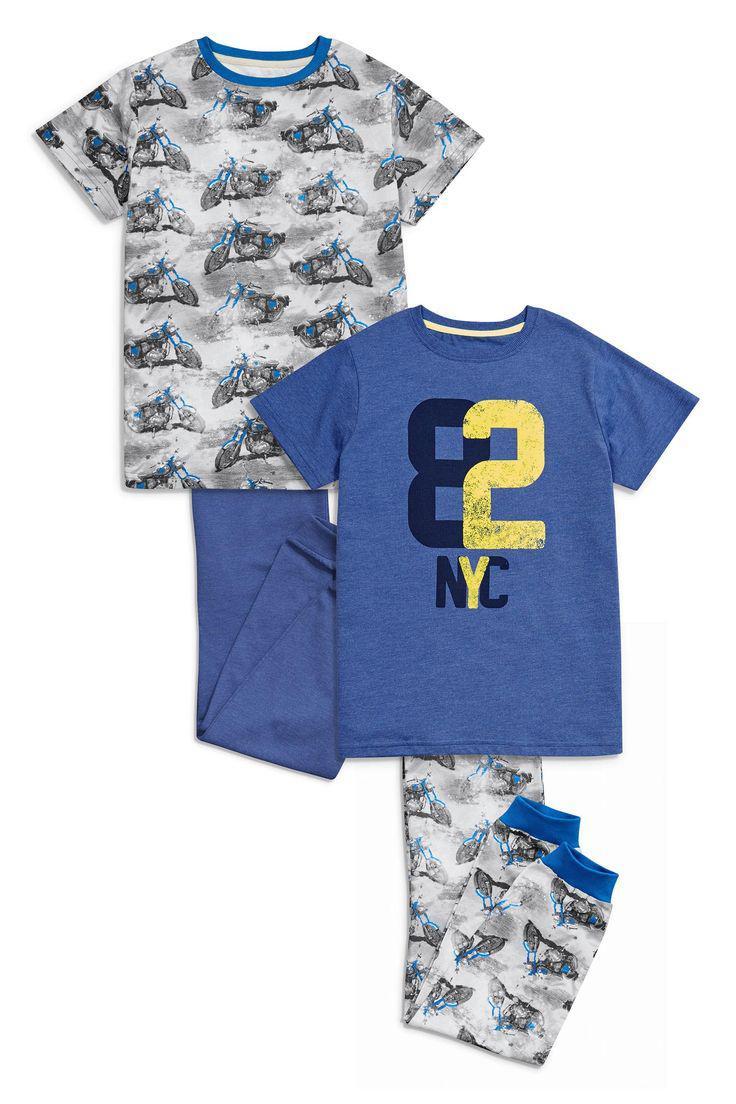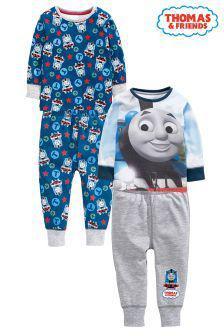The first image is the image on the left, the second image is the image on the right. Analyze the images presented: Is the assertion "No individual image contains more than two sets of sleepwear, and the right image includes a pajama top depicting a cartoon train face." valid? Answer yes or no. Yes. The first image is the image on the left, the second image is the image on the right. For the images displayed, is the sentence "There are two sets of pajamas in each of the images." factually correct? Answer yes or no. Yes. 